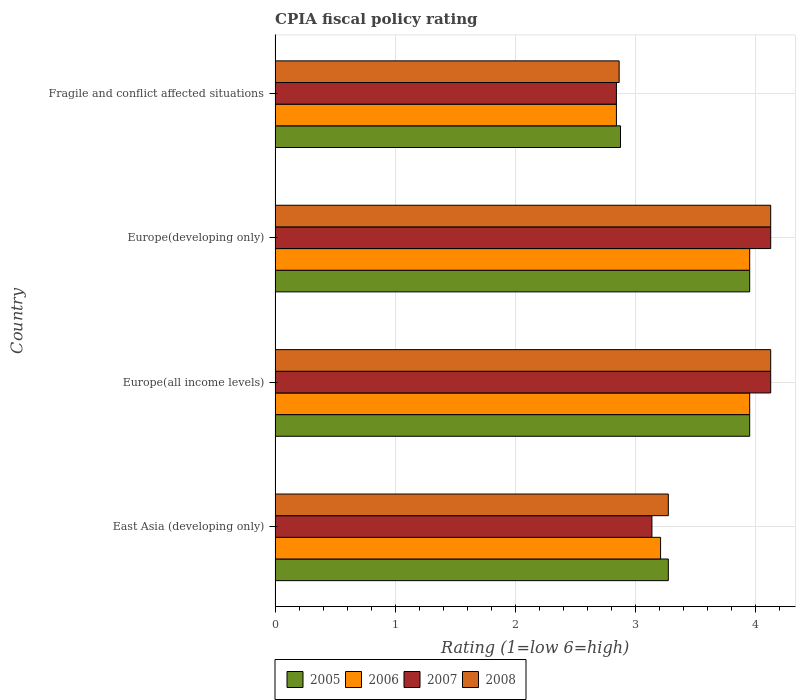How many different coloured bars are there?
Provide a short and direct response. 4. Are the number of bars per tick equal to the number of legend labels?
Make the answer very short. Yes. What is the label of the 1st group of bars from the top?
Keep it short and to the point. Fragile and conflict affected situations. In how many cases, is the number of bars for a given country not equal to the number of legend labels?
Keep it short and to the point. 0. What is the CPIA rating in 2006 in Europe(all income levels)?
Offer a terse response. 3.95. Across all countries, what is the maximum CPIA rating in 2007?
Your response must be concise. 4.12. Across all countries, what is the minimum CPIA rating in 2008?
Provide a succinct answer. 2.86. In which country was the CPIA rating in 2006 maximum?
Offer a very short reply. Europe(all income levels). In which country was the CPIA rating in 2005 minimum?
Your answer should be very brief. Fragile and conflict affected situations. What is the total CPIA rating in 2005 in the graph?
Provide a short and direct response. 14.05. What is the difference between the CPIA rating in 2007 in Fragile and conflict affected situations and the CPIA rating in 2006 in Europe(developing only)?
Make the answer very short. -1.11. What is the average CPIA rating in 2008 per country?
Make the answer very short. 3.6. What is the difference between the CPIA rating in 2005 and CPIA rating in 2006 in Fragile and conflict affected situations?
Make the answer very short. 0.03. What is the ratio of the CPIA rating in 2008 in East Asia (developing only) to that in Europe(all income levels)?
Give a very brief answer. 0.79. Is the CPIA rating in 2008 in Europe(all income levels) less than that in Europe(developing only)?
Offer a terse response. No. What is the difference between the highest and the second highest CPIA rating in 2006?
Provide a short and direct response. 0. What is the difference between the highest and the lowest CPIA rating in 2008?
Your response must be concise. 1.26. In how many countries, is the CPIA rating in 2008 greater than the average CPIA rating in 2008 taken over all countries?
Offer a very short reply. 2. Is it the case that in every country, the sum of the CPIA rating in 2005 and CPIA rating in 2008 is greater than the CPIA rating in 2007?
Your response must be concise. Yes. How many bars are there?
Ensure brevity in your answer.  16. Are all the bars in the graph horizontal?
Provide a succinct answer. Yes. What is the difference between two consecutive major ticks on the X-axis?
Your response must be concise. 1. Are the values on the major ticks of X-axis written in scientific E-notation?
Offer a terse response. No. Does the graph contain any zero values?
Your response must be concise. No. What is the title of the graph?
Make the answer very short. CPIA fiscal policy rating. Does "1975" appear as one of the legend labels in the graph?
Your answer should be very brief. No. What is the label or title of the X-axis?
Provide a short and direct response. Rating (1=low 6=high). What is the Rating (1=low 6=high) in 2005 in East Asia (developing only)?
Keep it short and to the point. 3.27. What is the Rating (1=low 6=high) of 2006 in East Asia (developing only)?
Give a very brief answer. 3.21. What is the Rating (1=low 6=high) of 2007 in East Asia (developing only)?
Your answer should be very brief. 3.14. What is the Rating (1=low 6=high) of 2008 in East Asia (developing only)?
Keep it short and to the point. 3.27. What is the Rating (1=low 6=high) of 2005 in Europe(all income levels)?
Offer a very short reply. 3.95. What is the Rating (1=low 6=high) of 2006 in Europe(all income levels)?
Your answer should be compact. 3.95. What is the Rating (1=low 6=high) of 2007 in Europe(all income levels)?
Your response must be concise. 4.12. What is the Rating (1=low 6=high) of 2008 in Europe(all income levels)?
Offer a terse response. 4.12. What is the Rating (1=low 6=high) of 2005 in Europe(developing only)?
Offer a very short reply. 3.95. What is the Rating (1=low 6=high) of 2006 in Europe(developing only)?
Your response must be concise. 3.95. What is the Rating (1=low 6=high) of 2007 in Europe(developing only)?
Your response must be concise. 4.12. What is the Rating (1=low 6=high) in 2008 in Europe(developing only)?
Keep it short and to the point. 4.12. What is the Rating (1=low 6=high) of 2005 in Fragile and conflict affected situations?
Your answer should be very brief. 2.88. What is the Rating (1=low 6=high) in 2006 in Fragile and conflict affected situations?
Your answer should be compact. 2.84. What is the Rating (1=low 6=high) in 2007 in Fragile and conflict affected situations?
Make the answer very short. 2.84. What is the Rating (1=low 6=high) of 2008 in Fragile and conflict affected situations?
Provide a short and direct response. 2.86. Across all countries, what is the maximum Rating (1=low 6=high) of 2005?
Give a very brief answer. 3.95. Across all countries, what is the maximum Rating (1=low 6=high) in 2006?
Your answer should be compact. 3.95. Across all countries, what is the maximum Rating (1=low 6=high) of 2007?
Provide a short and direct response. 4.12. Across all countries, what is the maximum Rating (1=low 6=high) in 2008?
Ensure brevity in your answer.  4.12. Across all countries, what is the minimum Rating (1=low 6=high) of 2005?
Your answer should be very brief. 2.88. Across all countries, what is the minimum Rating (1=low 6=high) of 2006?
Ensure brevity in your answer.  2.84. Across all countries, what is the minimum Rating (1=low 6=high) of 2007?
Make the answer very short. 2.84. Across all countries, what is the minimum Rating (1=low 6=high) of 2008?
Provide a short and direct response. 2.86. What is the total Rating (1=low 6=high) of 2005 in the graph?
Offer a terse response. 14.05. What is the total Rating (1=low 6=high) in 2006 in the graph?
Your response must be concise. 13.95. What is the total Rating (1=low 6=high) of 2007 in the graph?
Keep it short and to the point. 14.23. What is the total Rating (1=low 6=high) of 2008 in the graph?
Ensure brevity in your answer.  14.39. What is the difference between the Rating (1=low 6=high) in 2005 in East Asia (developing only) and that in Europe(all income levels)?
Ensure brevity in your answer.  -0.68. What is the difference between the Rating (1=low 6=high) in 2006 in East Asia (developing only) and that in Europe(all income levels)?
Offer a terse response. -0.74. What is the difference between the Rating (1=low 6=high) in 2007 in East Asia (developing only) and that in Europe(all income levels)?
Ensure brevity in your answer.  -0.99. What is the difference between the Rating (1=low 6=high) in 2008 in East Asia (developing only) and that in Europe(all income levels)?
Give a very brief answer. -0.85. What is the difference between the Rating (1=low 6=high) in 2005 in East Asia (developing only) and that in Europe(developing only)?
Make the answer very short. -0.68. What is the difference between the Rating (1=low 6=high) in 2006 in East Asia (developing only) and that in Europe(developing only)?
Give a very brief answer. -0.74. What is the difference between the Rating (1=low 6=high) of 2007 in East Asia (developing only) and that in Europe(developing only)?
Offer a very short reply. -0.99. What is the difference between the Rating (1=low 6=high) in 2008 in East Asia (developing only) and that in Europe(developing only)?
Your answer should be compact. -0.85. What is the difference between the Rating (1=low 6=high) in 2005 in East Asia (developing only) and that in Fragile and conflict affected situations?
Provide a short and direct response. 0.4. What is the difference between the Rating (1=low 6=high) of 2006 in East Asia (developing only) and that in Fragile and conflict affected situations?
Keep it short and to the point. 0.37. What is the difference between the Rating (1=low 6=high) in 2007 in East Asia (developing only) and that in Fragile and conflict affected situations?
Offer a very short reply. 0.3. What is the difference between the Rating (1=low 6=high) in 2008 in East Asia (developing only) and that in Fragile and conflict affected situations?
Ensure brevity in your answer.  0.41. What is the difference between the Rating (1=low 6=high) of 2005 in Europe(all income levels) and that in Europe(developing only)?
Offer a terse response. 0. What is the difference between the Rating (1=low 6=high) of 2006 in Europe(all income levels) and that in Europe(developing only)?
Give a very brief answer. 0. What is the difference between the Rating (1=low 6=high) of 2007 in Europe(all income levels) and that in Europe(developing only)?
Give a very brief answer. 0. What is the difference between the Rating (1=low 6=high) in 2008 in Europe(all income levels) and that in Europe(developing only)?
Offer a terse response. 0. What is the difference between the Rating (1=low 6=high) of 2005 in Europe(all income levels) and that in Fragile and conflict affected situations?
Offer a terse response. 1.07. What is the difference between the Rating (1=low 6=high) of 2006 in Europe(all income levels) and that in Fragile and conflict affected situations?
Ensure brevity in your answer.  1.11. What is the difference between the Rating (1=low 6=high) in 2007 in Europe(all income levels) and that in Fragile and conflict affected situations?
Your response must be concise. 1.28. What is the difference between the Rating (1=low 6=high) in 2008 in Europe(all income levels) and that in Fragile and conflict affected situations?
Offer a terse response. 1.26. What is the difference between the Rating (1=low 6=high) in 2005 in Europe(developing only) and that in Fragile and conflict affected situations?
Your answer should be very brief. 1.07. What is the difference between the Rating (1=low 6=high) in 2006 in Europe(developing only) and that in Fragile and conflict affected situations?
Provide a short and direct response. 1.11. What is the difference between the Rating (1=low 6=high) in 2007 in Europe(developing only) and that in Fragile and conflict affected situations?
Your answer should be very brief. 1.28. What is the difference between the Rating (1=low 6=high) of 2008 in Europe(developing only) and that in Fragile and conflict affected situations?
Your answer should be compact. 1.26. What is the difference between the Rating (1=low 6=high) in 2005 in East Asia (developing only) and the Rating (1=low 6=high) in 2006 in Europe(all income levels)?
Ensure brevity in your answer.  -0.68. What is the difference between the Rating (1=low 6=high) in 2005 in East Asia (developing only) and the Rating (1=low 6=high) in 2007 in Europe(all income levels)?
Provide a short and direct response. -0.85. What is the difference between the Rating (1=low 6=high) of 2005 in East Asia (developing only) and the Rating (1=low 6=high) of 2008 in Europe(all income levels)?
Make the answer very short. -0.85. What is the difference between the Rating (1=low 6=high) of 2006 in East Asia (developing only) and the Rating (1=low 6=high) of 2007 in Europe(all income levels)?
Offer a very short reply. -0.92. What is the difference between the Rating (1=low 6=high) of 2006 in East Asia (developing only) and the Rating (1=low 6=high) of 2008 in Europe(all income levels)?
Keep it short and to the point. -0.92. What is the difference between the Rating (1=low 6=high) in 2007 in East Asia (developing only) and the Rating (1=low 6=high) in 2008 in Europe(all income levels)?
Keep it short and to the point. -0.99. What is the difference between the Rating (1=low 6=high) in 2005 in East Asia (developing only) and the Rating (1=low 6=high) in 2006 in Europe(developing only)?
Your response must be concise. -0.68. What is the difference between the Rating (1=low 6=high) in 2005 in East Asia (developing only) and the Rating (1=low 6=high) in 2007 in Europe(developing only)?
Your response must be concise. -0.85. What is the difference between the Rating (1=low 6=high) in 2005 in East Asia (developing only) and the Rating (1=low 6=high) in 2008 in Europe(developing only)?
Provide a short and direct response. -0.85. What is the difference between the Rating (1=low 6=high) of 2006 in East Asia (developing only) and the Rating (1=low 6=high) of 2007 in Europe(developing only)?
Offer a very short reply. -0.92. What is the difference between the Rating (1=low 6=high) of 2006 in East Asia (developing only) and the Rating (1=low 6=high) of 2008 in Europe(developing only)?
Keep it short and to the point. -0.92. What is the difference between the Rating (1=low 6=high) in 2007 in East Asia (developing only) and the Rating (1=low 6=high) in 2008 in Europe(developing only)?
Give a very brief answer. -0.99. What is the difference between the Rating (1=low 6=high) in 2005 in East Asia (developing only) and the Rating (1=low 6=high) in 2006 in Fragile and conflict affected situations?
Make the answer very short. 0.43. What is the difference between the Rating (1=low 6=high) in 2005 in East Asia (developing only) and the Rating (1=low 6=high) in 2007 in Fragile and conflict affected situations?
Ensure brevity in your answer.  0.43. What is the difference between the Rating (1=low 6=high) of 2005 in East Asia (developing only) and the Rating (1=low 6=high) of 2008 in Fragile and conflict affected situations?
Offer a very short reply. 0.41. What is the difference between the Rating (1=low 6=high) of 2006 in East Asia (developing only) and the Rating (1=low 6=high) of 2007 in Fragile and conflict affected situations?
Keep it short and to the point. 0.37. What is the difference between the Rating (1=low 6=high) of 2006 in East Asia (developing only) and the Rating (1=low 6=high) of 2008 in Fragile and conflict affected situations?
Offer a terse response. 0.34. What is the difference between the Rating (1=low 6=high) in 2007 in East Asia (developing only) and the Rating (1=low 6=high) in 2008 in Fragile and conflict affected situations?
Your response must be concise. 0.27. What is the difference between the Rating (1=low 6=high) of 2005 in Europe(all income levels) and the Rating (1=low 6=high) of 2006 in Europe(developing only)?
Offer a terse response. 0. What is the difference between the Rating (1=low 6=high) in 2005 in Europe(all income levels) and the Rating (1=low 6=high) in 2007 in Europe(developing only)?
Provide a succinct answer. -0.17. What is the difference between the Rating (1=low 6=high) in 2005 in Europe(all income levels) and the Rating (1=low 6=high) in 2008 in Europe(developing only)?
Offer a terse response. -0.17. What is the difference between the Rating (1=low 6=high) in 2006 in Europe(all income levels) and the Rating (1=low 6=high) in 2007 in Europe(developing only)?
Keep it short and to the point. -0.17. What is the difference between the Rating (1=low 6=high) of 2006 in Europe(all income levels) and the Rating (1=low 6=high) of 2008 in Europe(developing only)?
Provide a succinct answer. -0.17. What is the difference between the Rating (1=low 6=high) in 2007 in Europe(all income levels) and the Rating (1=low 6=high) in 2008 in Europe(developing only)?
Offer a very short reply. 0. What is the difference between the Rating (1=low 6=high) of 2005 in Europe(all income levels) and the Rating (1=low 6=high) of 2006 in Fragile and conflict affected situations?
Your response must be concise. 1.11. What is the difference between the Rating (1=low 6=high) in 2005 in Europe(all income levels) and the Rating (1=low 6=high) in 2007 in Fragile and conflict affected situations?
Provide a succinct answer. 1.11. What is the difference between the Rating (1=low 6=high) in 2005 in Europe(all income levels) and the Rating (1=low 6=high) in 2008 in Fragile and conflict affected situations?
Provide a short and direct response. 1.09. What is the difference between the Rating (1=low 6=high) in 2006 in Europe(all income levels) and the Rating (1=low 6=high) in 2007 in Fragile and conflict affected situations?
Give a very brief answer. 1.11. What is the difference between the Rating (1=low 6=high) in 2006 in Europe(all income levels) and the Rating (1=low 6=high) in 2008 in Fragile and conflict affected situations?
Keep it short and to the point. 1.09. What is the difference between the Rating (1=low 6=high) of 2007 in Europe(all income levels) and the Rating (1=low 6=high) of 2008 in Fragile and conflict affected situations?
Provide a succinct answer. 1.26. What is the difference between the Rating (1=low 6=high) in 2005 in Europe(developing only) and the Rating (1=low 6=high) in 2006 in Fragile and conflict affected situations?
Your answer should be compact. 1.11. What is the difference between the Rating (1=low 6=high) of 2005 in Europe(developing only) and the Rating (1=low 6=high) of 2007 in Fragile and conflict affected situations?
Keep it short and to the point. 1.11. What is the difference between the Rating (1=low 6=high) in 2005 in Europe(developing only) and the Rating (1=low 6=high) in 2008 in Fragile and conflict affected situations?
Give a very brief answer. 1.09. What is the difference between the Rating (1=low 6=high) of 2006 in Europe(developing only) and the Rating (1=low 6=high) of 2007 in Fragile and conflict affected situations?
Offer a terse response. 1.11. What is the difference between the Rating (1=low 6=high) in 2006 in Europe(developing only) and the Rating (1=low 6=high) in 2008 in Fragile and conflict affected situations?
Your response must be concise. 1.09. What is the difference between the Rating (1=low 6=high) in 2007 in Europe(developing only) and the Rating (1=low 6=high) in 2008 in Fragile and conflict affected situations?
Make the answer very short. 1.26. What is the average Rating (1=low 6=high) in 2005 per country?
Make the answer very short. 3.51. What is the average Rating (1=low 6=high) in 2006 per country?
Keep it short and to the point. 3.49. What is the average Rating (1=low 6=high) in 2007 per country?
Provide a short and direct response. 3.56. What is the average Rating (1=low 6=high) of 2008 per country?
Provide a short and direct response. 3.6. What is the difference between the Rating (1=low 6=high) in 2005 and Rating (1=low 6=high) in 2006 in East Asia (developing only)?
Your response must be concise. 0.06. What is the difference between the Rating (1=low 6=high) of 2005 and Rating (1=low 6=high) of 2007 in East Asia (developing only)?
Give a very brief answer. 0.14. What is the difference between the Rating (1=low 6=high) in 2005 and Rating (1=low 6=high) in 2008 in East Asia (developing only)?
Offer a very short reply. 0. What is the difference between the Rating (1=low 6=high) in 2006 and Rating (1=low 6=high) in 2007 in East Asia (developing only)?
Keep it short and to the point. 0.07. What is the difference between the Rating (1=low 6=high) in 2006 and Rating (1=low 6=high) in 2008 in East Asia (developing only)?
Ensure brevity in your answer.  -0.06. What is the difference between the Rating (1=low 6=high) of 2007 and Rating (1=low 6=high) of 2008 in East Asia (developing only)?
Ensure brevity in your answer.  -0.14. What is the difference between the Rating (1=low 6=high) of 2005 and Rating (1=low 6=high) of 2007 in Europe(all income levels)?
Provide a succinct answer. -0.17. What is the difference between the Rating (1=low 6=high) in 2005 and Rating (1=low 6=high) in 2008 in Europe(all income levels)?
Provide a short and direct response. -0.17. What is the difference between the Rating (1=low 6=high) in 2006 and Rating (1=low 6=high) in 2007 in Europe(all income levels)?
Your response must be concise. -0.17. What is the difference between the Rating (1=low 6=high) of 2006 and Rating (1=low 6=high) of 2008 in Europe(all income levels)?
Your answer should be compact. -0.17. What is the difference between the Rating (1=low 6=high) of 2005 and Rating (1=low 6=high) of 2006 in Europe(developing only)?
Give a very brief answer. 0. What is the difference between the Rating (1=low 6=high) in 2005 and Rating (1=low 6=high) in 2007 in Europe(developing only)?
Provide a succinct answer. -0.17. What is the difference between the Rating (1=low 6=high) of 2005 and Rating (1=low 6=high) of 2008 in Europe(developing only)?
Give a very brief answer. -0.17. What is the difference between the Rating (1=low 6=high) of 2006 and Rating (1=low 6=high) of 2007 in Europe(developing only)?
Keep it short and to the point. -0.17. What is the difference between the Rating (1=low 6=high) of 2006 and Rating (1=low 6=high) of 2008 in Europe(developing only)?
Your answer should be compact. -0.17. What is the difference between the Rating (1=low 6=high) in 2005 and Rating (1=low 6=high) in 2006 in Fragile and conflict affected situations?
Offer a very short reply. 0.03. What is the difference between the Rating (1=low 6=high) in 2005 and Rating (1=low 6=high) in 2007 in Fragile and conflict affected situations?
Give a very brief answer. 0.03. What is the difference between the Rating (1=low 6=high) in 2005 and Rating (1=low 6=high) in 2008 in Fragile and conflict affected situations?
Your answer should be very brief. 0.01. What is the difference between the Rating (1=low 6=high) in 2006 and Rating (1=low 6=high) in 2008 in Fragile and conflict affected situations?
Provide a short and direct response. -0.02. What is the difference between the Rating (1=low 6=high) of 2007 and Rating (1=low 6=high) of 2008 in Fragile and conflict affected situations?
Ensure brevity in your answer.  -0.02. What is the ratio of the Rating (1=low 6=high) of 2005 in East Asia (developing only) to that in Europe(all income levels)?
Ensure brevity in your answer.  0.83. What is the ratio of the Rating (1=low 6=high) of 2006 in East Asia (developing only) to that in Europe(all income levels)?
Ensure brevity in your answer.  0.81. What is the ratio of the Rating (1=low 6=high) of 2007 in East Asia (developing only) to that in Europe(all income levels)?
Ensure brevity in your answer.  0.76. What is the ratio of the Rating (1=low 6=high) in 2008 in East Asia (developing only) to that in Europe(all income levels)?
Give a very brief answer. 0.79. What is the ratio of the Rating (1=low 6=high) of 2005 in East Asia (developing only) to that in Europe(developing only)?
Your answer should be compact. 0.83. What is the ratio of the Rating (1=low 6=high) of 2006 in East Asia (developing only) to that in Europe(developing only)?
Give a very brief answer. 0.81. What is the ratio of the Rating (1=low 6=high) in 2007 in East Asia (developing only) to that in Europe(developing only)?
Provide a short and direct response. 0.76. What is the ratio of the Rating (1=low 6=high) of 2008 in East Asia (developing only) to that in Europe(developing only)?
Provide a succinct answer. 0.79. What is the ratio of the Rating (1=low 6=high) of 2005 in East Asia (developing only) to that in Fragile and conflict affected situations?
Give a very brief answer. 1.14. What is the ratio of the Rating (1=low 6=high) of 2006 in East Asia (developing only) to that in Fragile and conflict affected situations?
Your response must be concise. 1.13. What is the ratio of the Rating (1=low 6=high) in 2007 in East Asia (developing only) to that in Fragile and conflict affected situations?
Your response must be concise. 1.1. What is the ratio of the Rating (1=low 6=high) in 2008 in East Asia (developing only) to that in Fragile and conflict affected situations?
Make the answer very short. 1.14. What is the ratio of the Rating (1=low 6=high) in 2006 in Europe(all income levels) to that in Europe(developing only)?
Offer a very short reply. 1. What is the ratio of the Rating (1=low 6=high) of 2007 in Europe(all income levels) to that in Europe(developing only)?
Your response must be concise. 1. What is the ratio of the Rating (1=low 6=high) in 2005 in Europe(all income levels) to that in Fragile and conflict affected situations?
Your answer should be very brief. 1.37. What is the ratio of the Rating (1=low 6=high) of 2006 in Europe(all income levels) to that in Fragile and conflict affected situations?
Offer a very short reply. 1.39. What is the ratio of the Rating (1=low 6=high) of 2007 in Europe(all income levels) to that in Fragile and conflict affected situations?
Your answer should be very brief. 1.45. What is the ratio of the Rating (1=low 6=high) of 2008 in Europe(all income levels) to that in Fragile and conflict affected situations?
Make the answer very short. 1.44. What is the ratio of the Rating (1=low 6=high) in 2005 in Europe(developing only) to that in Fragile and conflict affected situations?
Make the answer very short. 1.37. What is the ratio of the Rating (1=low 6=high) in 2006 in Europe(developing only) to that in Fragile and conflict affected situations?
Give a very brief answer. 1.39. What is the ratio of the Rating (1=low 6=high) of 2007 in Europe(developing only) to that in Fragile and conflict affected situations?
Provide a succinct answer. 1.45. What is the ratio of the Rating (1=low 6=high) of 2008 in Europe(developing only) to that in Fragile and conflict affected situations?
Provide a succinct answer. 1.44. What is the difference between the highest and the second highest Rating (1=low 6=high) in 2005?
Offer a very short reply. 0. What is the difference between the highest and the second highest Rating (1=low 6=high) in 2008?
Your answer should be very brief. 0. What is the difference between the highest and the lowest Rating (1=low 6=high) of 2005?
Provide a succinct answer. 1.07. What is the difference between the highest and the lowest Rating (1=low 6=high) in 2006?
Make the answer very short. 1.11. What is the difference between the highest and the lowest Rating (1=low 6=high) in 2007?
Your answer should be very brief. 1.28. What is the difference between the highest and the lowest Rating (1=low 6=high) of 2008?
Offer a very short reply. 1.26. 